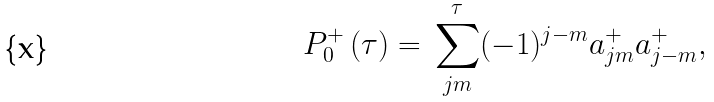Convert formula to latex. <formula><loc_0><loc_0><loc_500><loc_500>P _ { 0 } ^ { + } \, ( \tau ) = \, \sum _ { j m } ^ { \tau } ( - 1 ) ^ { j - m } a _ { j m } ^ { + } a _ { j - m } ^ { + } ,</formula> 